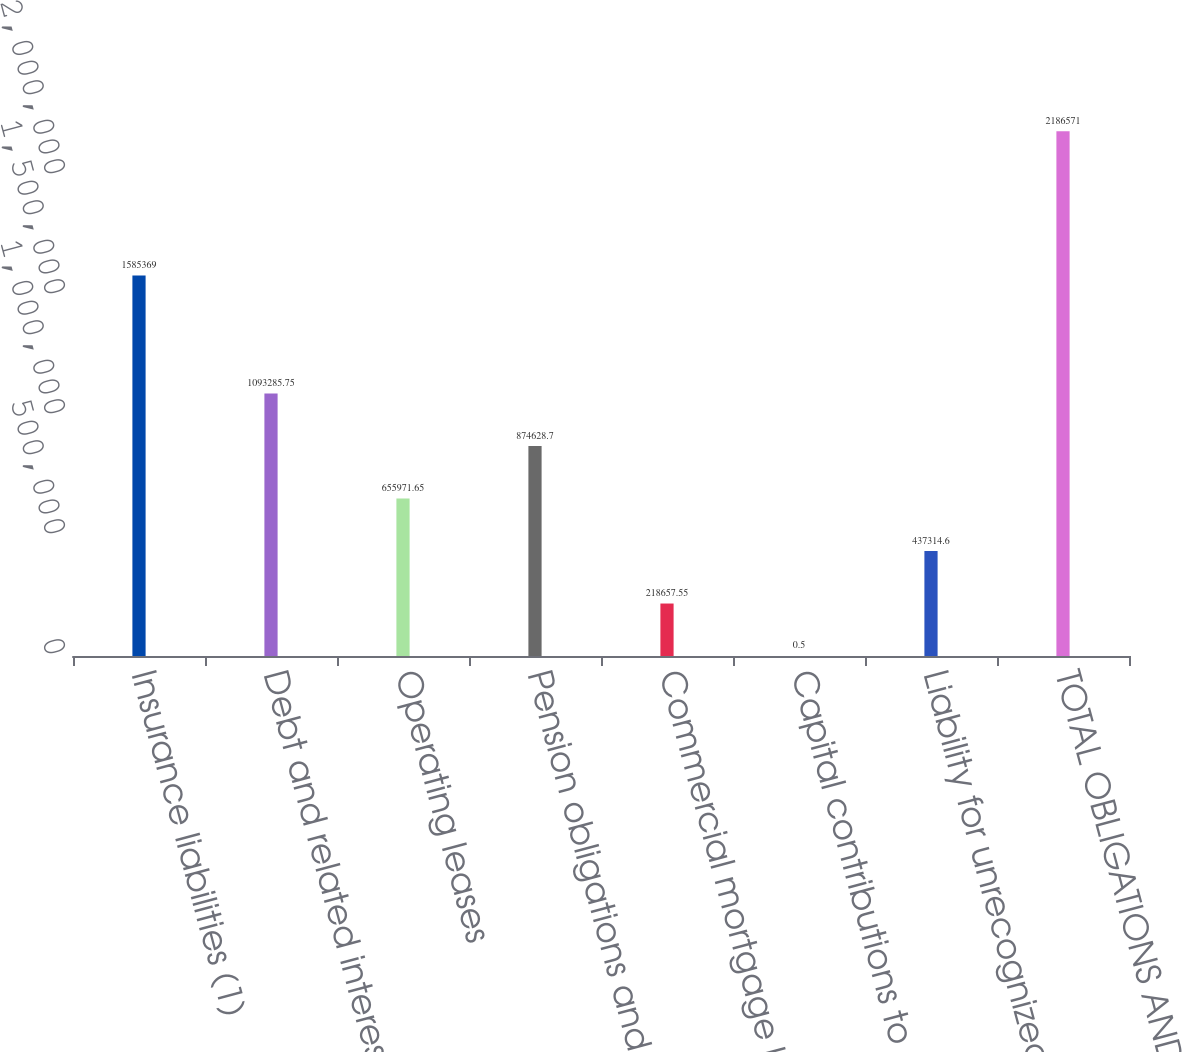<chart> <loc_0><loc_0><loc_500><loc_500><bar_chart><fcel>Insurance liabilities (1)<fcel>Debt and related interest<fcel>Operating leases<fcel>Pension obligations and<fcel>Commercial mortgage loans on<fcel>Capital contributions to real<fcel>Liability for unrecognized tax<fcel>TOTAL OBLIGATIONS AND<nl><fcel>1.58537e+06<fcel>1.09329e+06<fcel>655972<fcel>874629<fcel>218658<fcel>0.5<fcel>437315<fcel>2.18657e+06<nl></chart> 